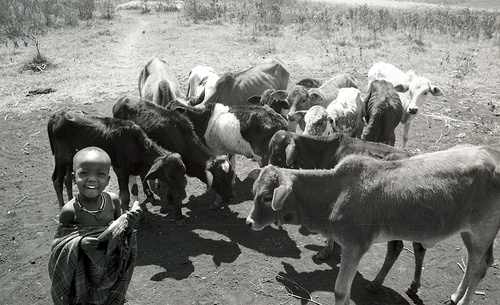Describe the objects in this image and their specific colors. I can see cow in gray, black, darkgray, and lightgray tones, people in gray, black, darkgray, and lightgray tones, cow in gray, black, and darkgray tones, cow in gray, black, darkgray, and white tones, and cow in gray, black, darkgray, and lightgray tones in this image. 